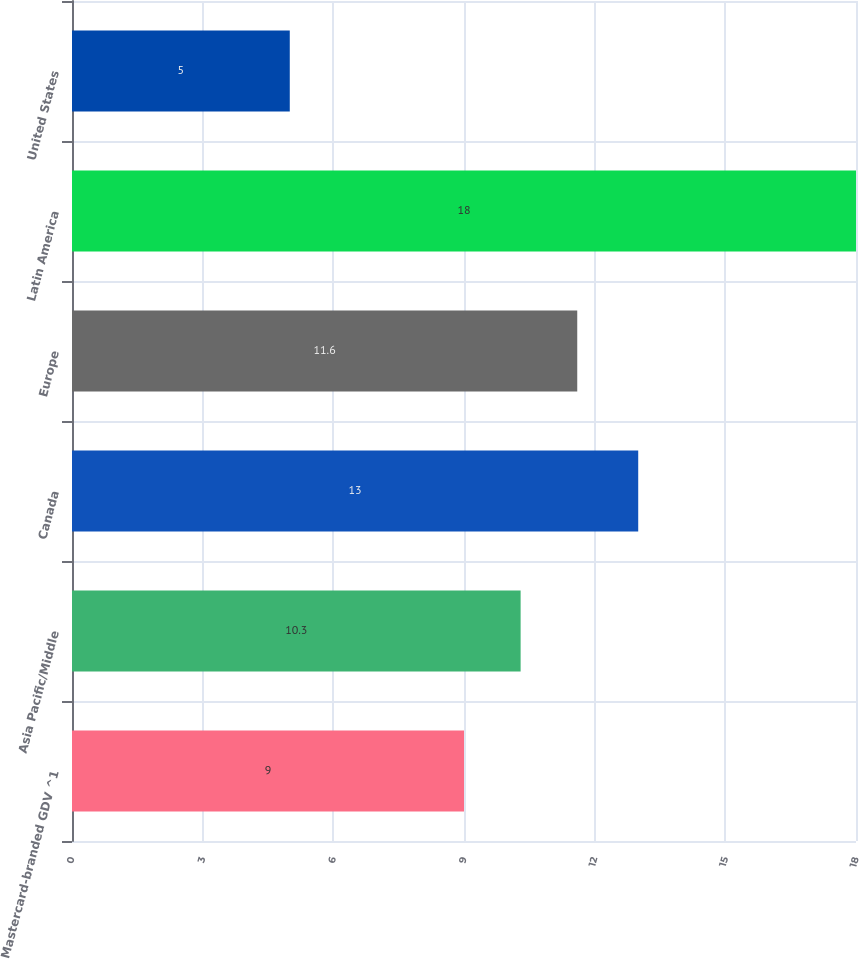Convert chart. <chart><loc_0><loc_0><loc_500><loc_500><bar_chart><fcel>Mastercard-branded GDV ^1<fcel>Asia Pacific/Middle<fcel>Canada<fcel>Europe<fcel>Latin America<fcel>United States<nl><fcel>9<fcel>10.3<fcel>13<fcel>11.6<fcel>18<fcel>5<nl></chart> 